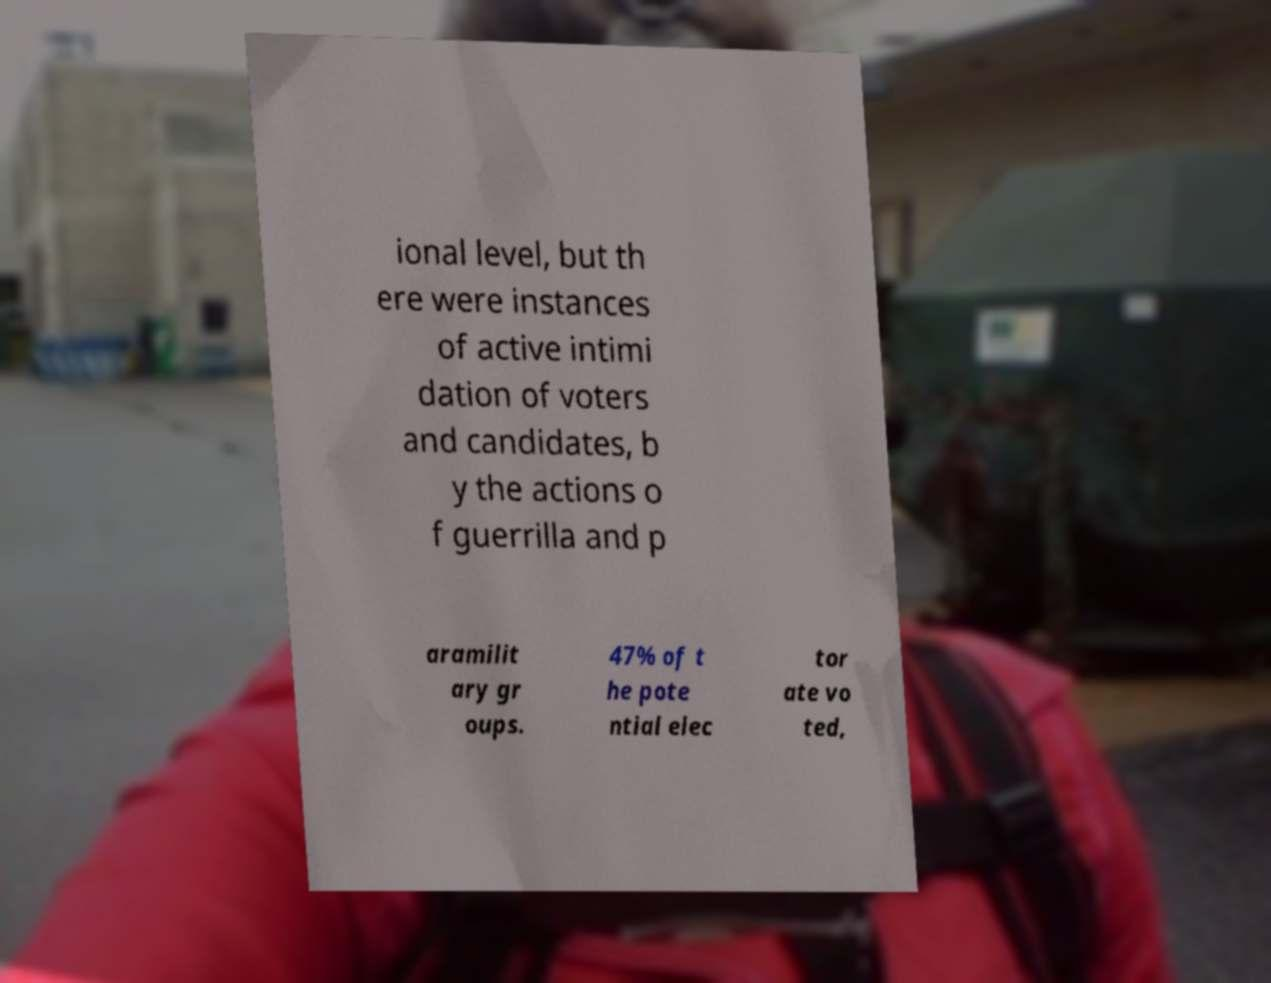There's text embedded in this image that I need extracted. Can you transcribe it verbatim? ional level, but th ere were instances of active intimi dation of voters and candidates, b y the actions o f guerrilla and p aramilit ary gr oups. 47% of t he pote ntial elec tor ate vo ted, 